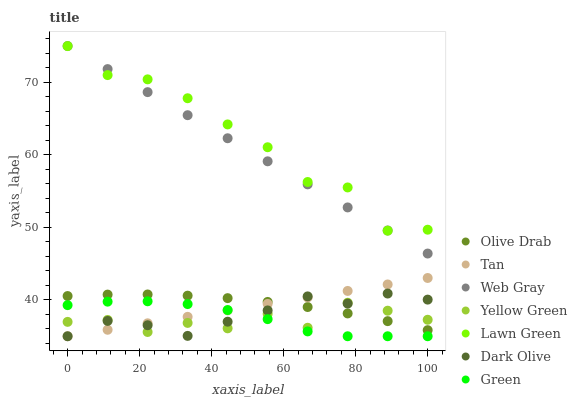Does Yellow Green have the minimum area under the curve?
Answer yes or no. Yes. Does Lawn Green have the maximum area under the curve?
Answer yes or no. Yes. Does Web Gray have the minimum area under the curve?
Answer yes or no. No. Does Web Gray have the maximum area under the curve?
Answer yes or no. No. Is Tan the smoothest?
Answer yes or no. Yes. Is Lawn Green the roughest?
Answer yes or no. Yes. Is Web Gray the smoothest?
Answer yes or no. No. Is Web Gray the roughest?
Answer yes or no. No. Does Dark Olive have the lowest value?
Answer yes or no. Yes. Does Web Gray have the lowest value?
Answer yes or no. No. Does Web Gray have the highest value?
Answer yes or no. Yes. Does Yellow Green have the highest value?
Answer yes or no. No. Is Green less than Lawn Green?
Answer yes or no. Yes. Is Lawn Green greater than Green?
Answer yes or no. Yes. Does Web Gray intersect Lawn Green?
Answer yes or no. Yes. Is Web Gray less than Lawn Green?
Answer yes or no. No. Is Web Gray greater than Lawn Green?
Answer yes or no. No. Does Green intersect Lawn Green?
Answer yes or no. No. 